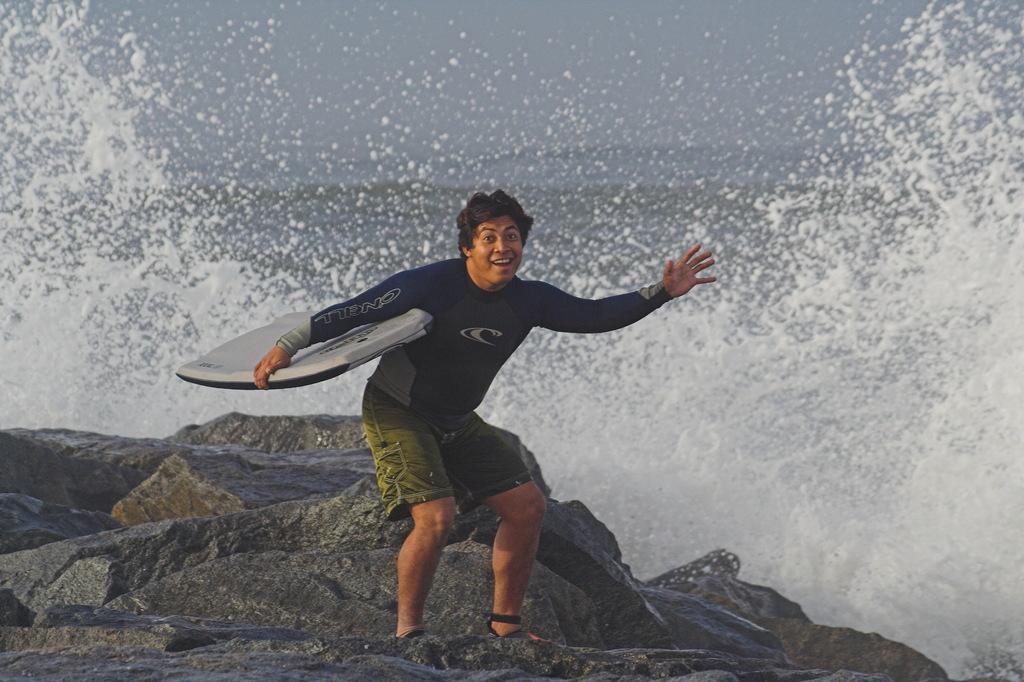Who is present in the image? There is a man in the picture. What is the man doing in the image? The man is standing and smiling. What is the man holding in the image? The man is holding a surfing board. What can be seen in the background of the image? There is water, sky, and a rock visible in the image. What is the man's opinion on the expansion of the local airport in the image? There is no information about the man's opinion on the expansion of the local airport in the image. 